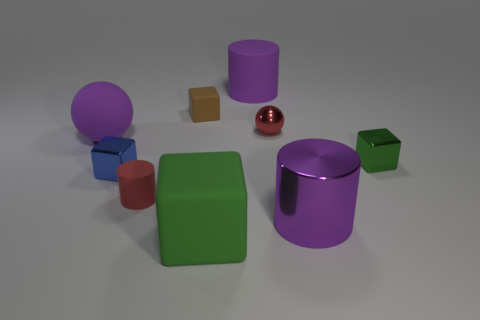Can you describe the lighting in the scene? The lighting in the scene appears to be a soft, diffused overhead source, which casts gentle shadows below the objects. The lack of harsh shadows suggests the light may be evenly distributed across the scene or simulated as a global illumination within a 3D environment. 